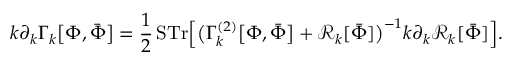Convert formula to latex. <formula><loc_0><loc_0><loc_500><loc_500>k \partial _ { k } \Gamma _ { k } { \left [ } \Phi , { \bar { \Phi } } { \right ] } = { \frac { 1 } { 2 } } \, { S T r } { \left [ } { \left ( } \Gamma _ { k } ^ { ( 2 ) } { \left [ } \Phi , { \bar { \Phi } } { \right ] } + { \mathcal { R } } _ { k } [ { \bar { \Phi } } ] { \right ) } ^ { - 1 } k \partial _ { k } { \mathcal { R } } _ { k } [ { \bar { \Phi } } ] { \right ] } .</formula> 